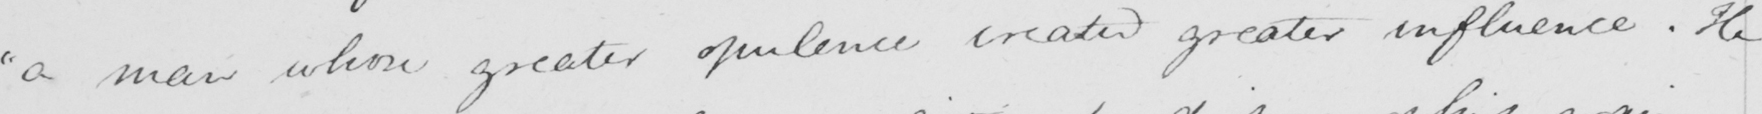What is written in this line of handwriting? " a man whose greater opulence created greater influence . He 